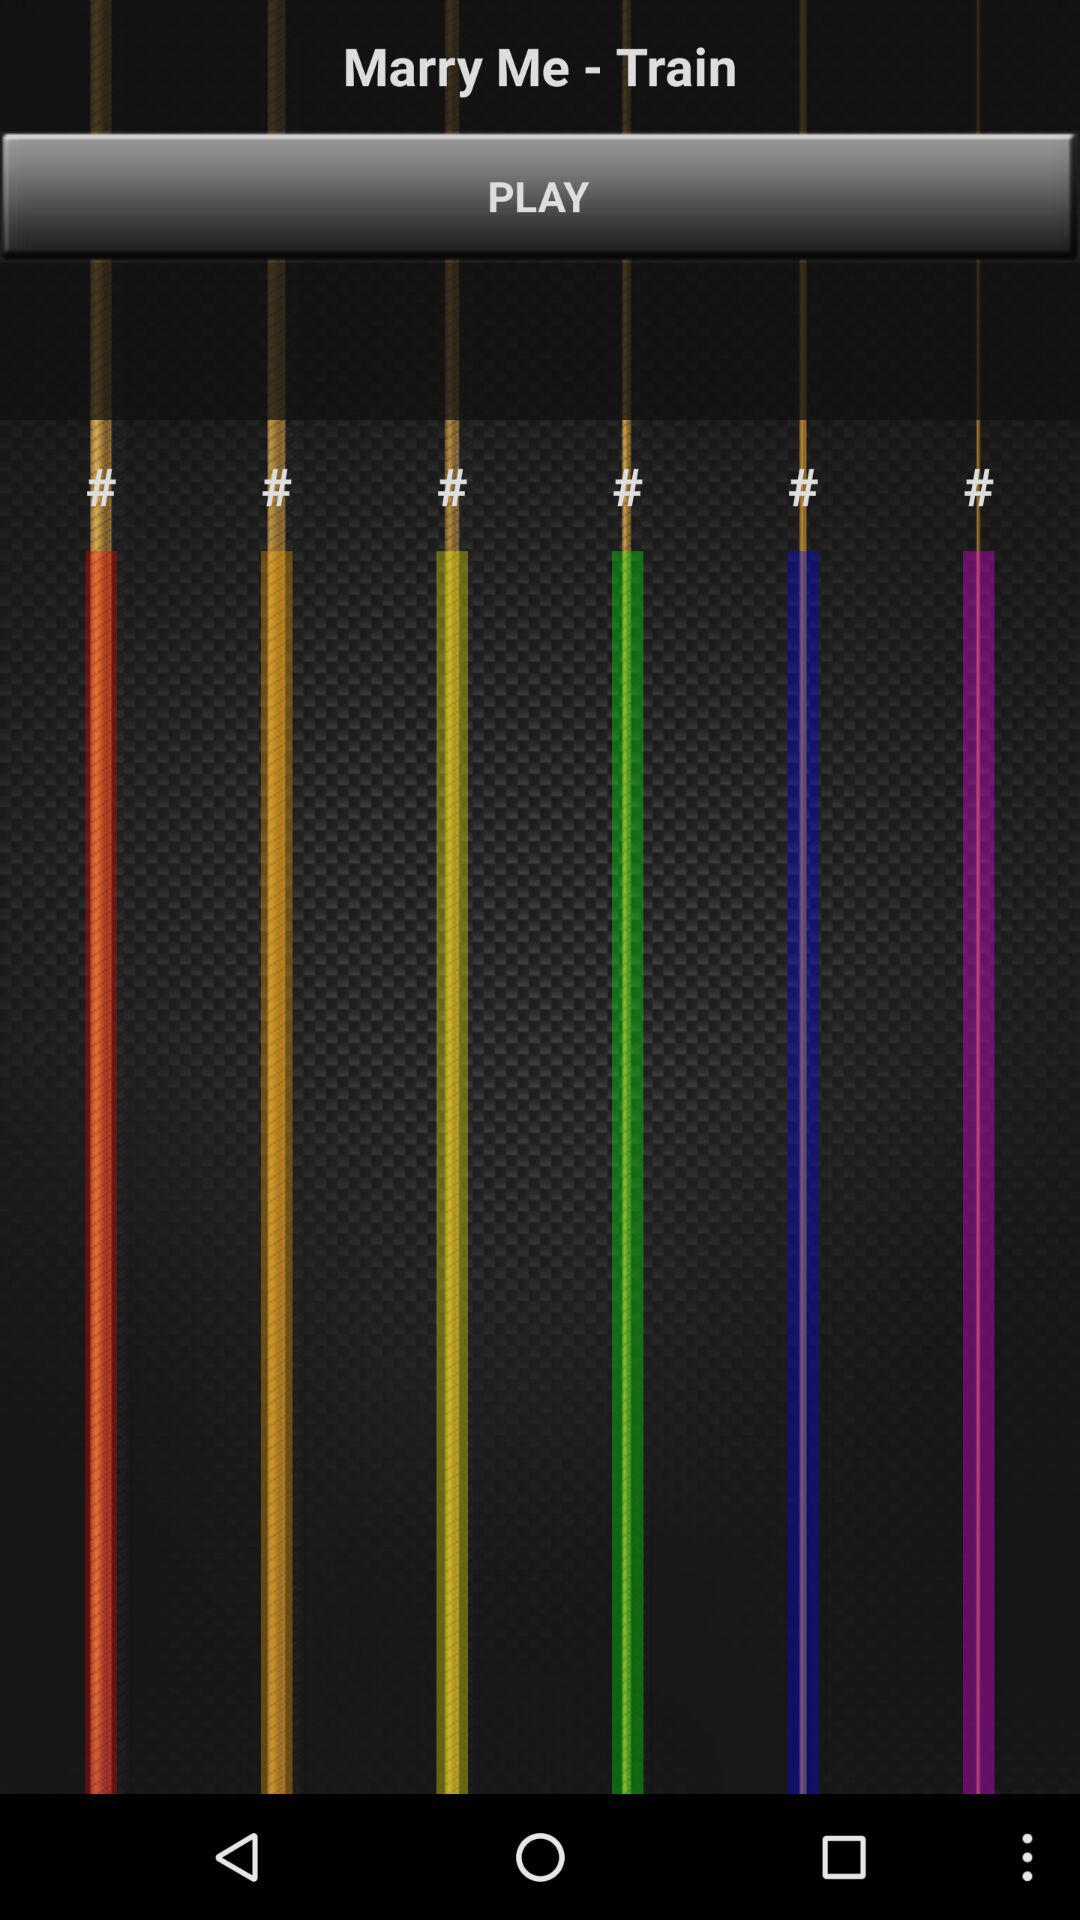How many lines are in the row of colored lines?
Answer the question using a single word or phrase. 6 